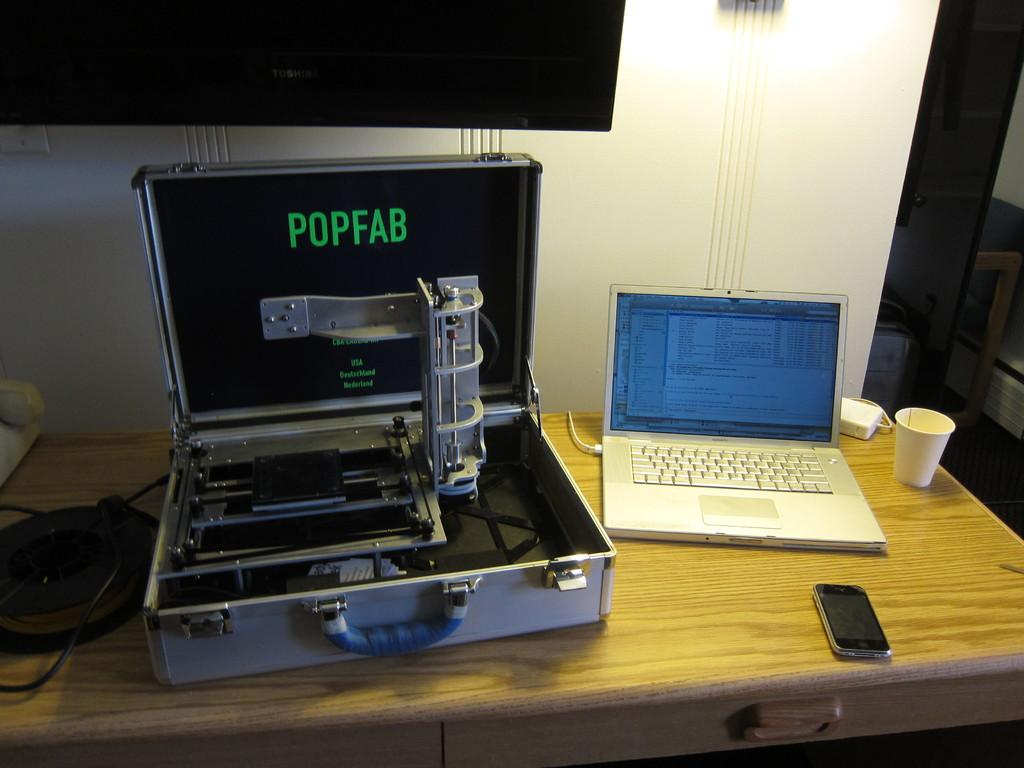What electronic device is visible on the table in the image? There is a laptop on the table in the image. What other electronic device can be seen in the image? There is a mobile phone in the image. What type of container is present on the table? There is a cup in the image. What other objects are on the wooden table? There are other objects on the wooden table, but their specific details are not mentioned in the facts. What is mounted on the wall behind the table? There is a television mounted on the wall behind the table. What type of yard is visible through the window in the image? There is no window or yard visible in the image; it only shows a table with electronic devices and other objects. 